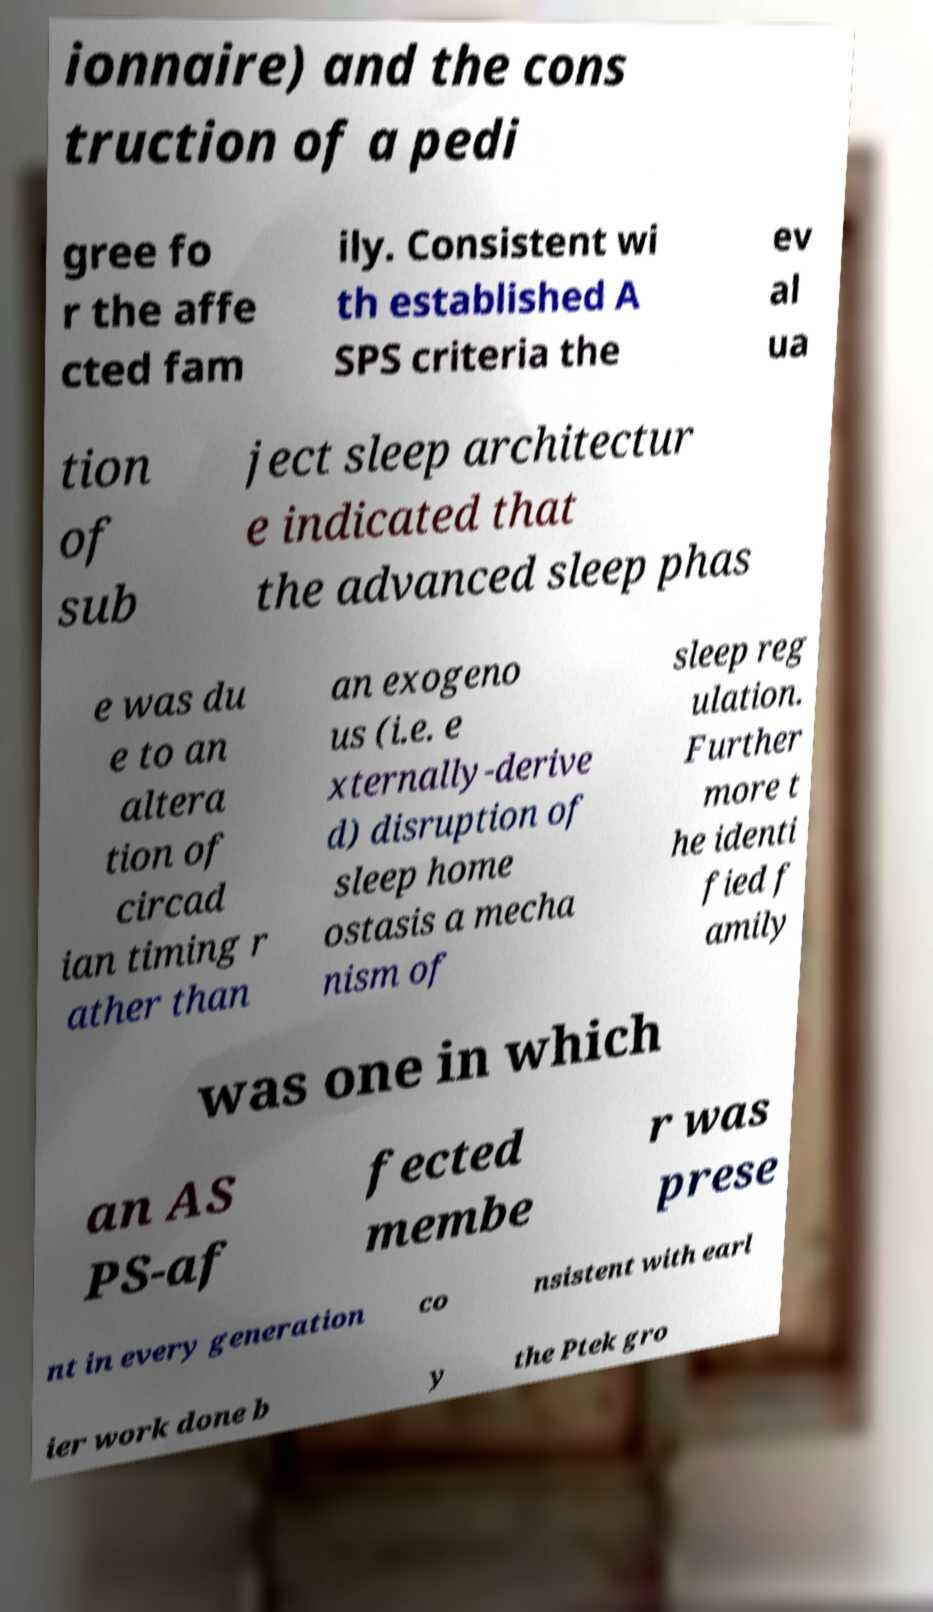Can you read and provide the text displayed in the image?This photo seems to have some interesting text. Can you extract and type it out for me? ionnaire) and the cons truction of a pedi gree fo r the affe cted fam ily. Consistent wi th established A SPS criteria the ev al ua tion of sub ject sleep architectur e indicated that the advanced sleep phas e was du e to an altera tion of circad ian timing r ather than an exogeno us (i.e. e xternally-derive d) disruption of sleep home ostasis a mecha nism of sleep reg ulation. Further more t he identi fied f amily was one in which an AS PS-af fected membe r was prese nt in every generation co nsistent with earl ier work done b y the Ptek gro 